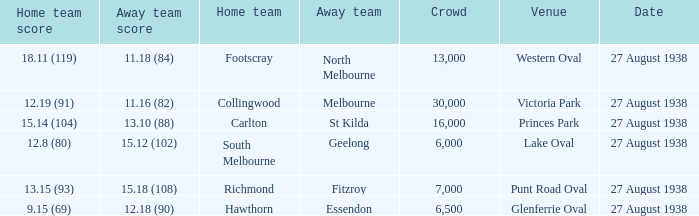Can you parse all the data within this table? {'header': ['Home team score', 'Away team score', 'Home team', 'Away team', 'Crowd', 'Venue', 'Date'], 'rows': [['18.11 (119)', '11.18 (84)', 'Footscray', 'North Melbourne', '13,000', 'Western Oval', '27 August 1938'], ['12.19 (91)', '11.16 (82)', 'Collingwood', 'Melbourne', '30,000', 'Victoria Park', '27 August 1938'], ['15.14 (104)', '13.10 (88)', 'Carlton', 'St Kilda', '16,000', 'Princes Park', '27 August 1938'], ['12.8 (80)', '15.12 (102)', 'South Melbourne', 'Geelong', '6,000', 'Lake Oval', '27 August 1938'], ['13.15 (93)', '15.18 (108)', 'Richmond', 'Fitzroy', '7,000', 'Punt Road Oval', '27 August 1938'], ['9.15 (69)', '12.18 (90)', 'Hawthorn', 'Essendon', '6,500', 'Glenferrie Oval', '27 August 1938']]} What is the average crowd attendance for Collingwood? 30000.0. 